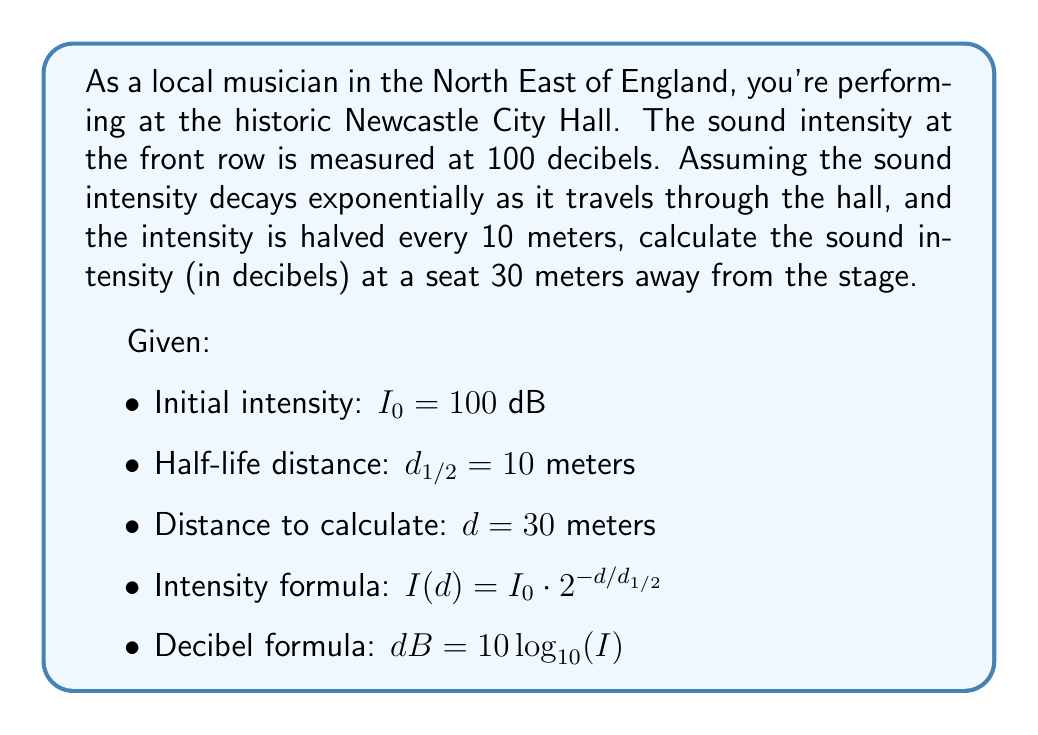Can you solve this math problem? To solve this problem, we'll follow these steps:

1) First, we need to find the decay constant $k$ using the half-life distance:

   $\frac{1}{2} = 2^{-d_{1/2}/d_{1/2}} = 2^{-1} = 2^{-k}$
   
   So, $k = 1$

2) Now we can use the intensity formula to find the intensity at 30 meters:

   $I(30) = 100 \cdot 2^{-30/10} = 100 \cdot 2^{-3} = 100 \cdot \frac{1}{8} = 12.5$

3) To convert this intensity to decibels, we use the decibel formula:

   $dB = 10 \log_{10}(12.5)$

4) Calculate the logarithm:

   $\log_{10}(12.5) \approx 1.0969$

5) Multiply by 10:

   $10 \cdot 1.0969 \approx 10.969$

Therefore, the sound intensity at 30 meters from the stage is approximately 10.969 decibels.
Answer: The sound intensity 30 meters away from the stage is approximately 10.97 dB. 